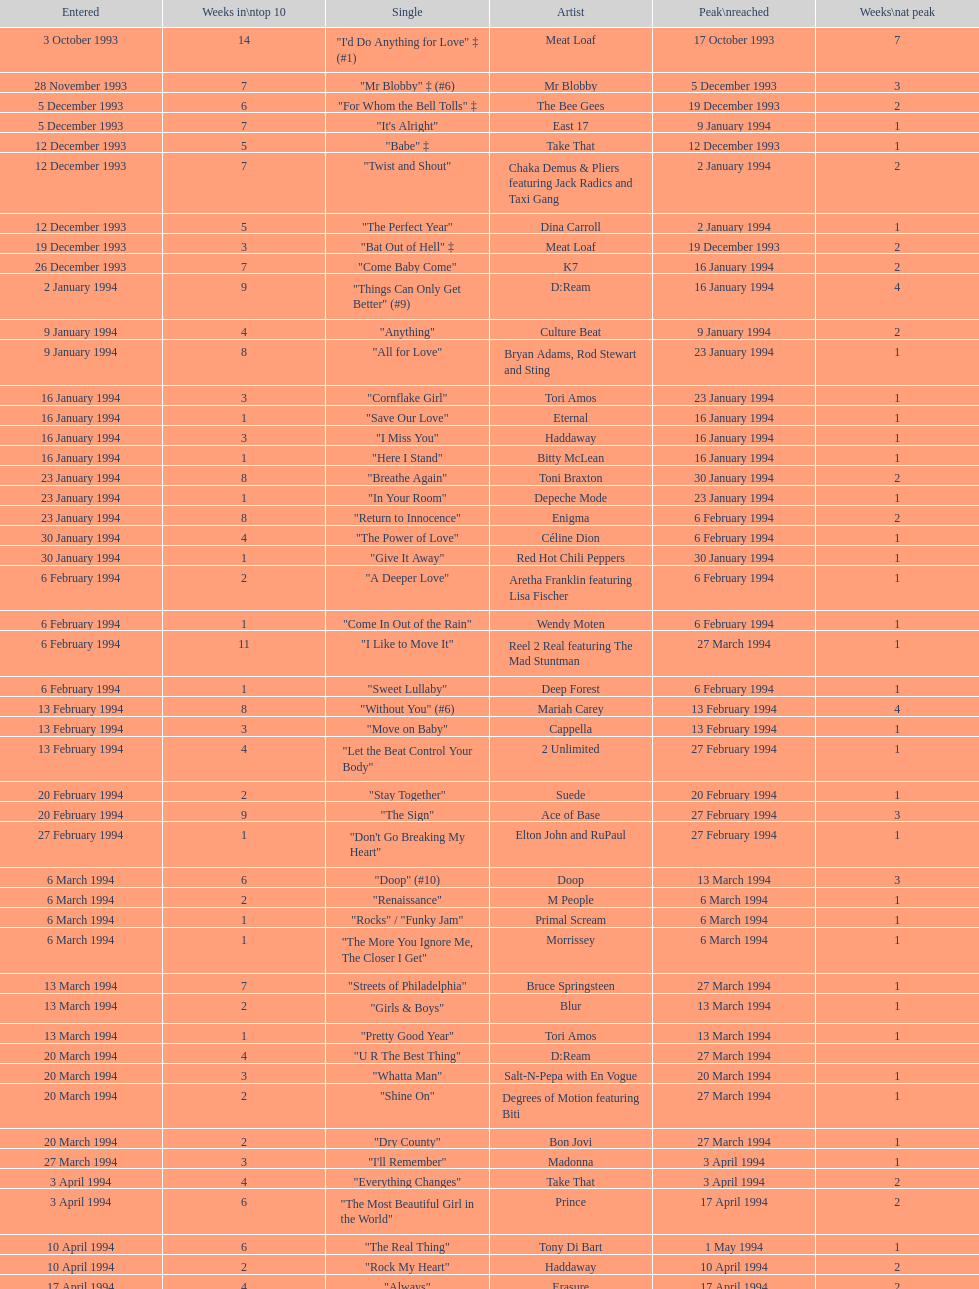Which single was the last one to be on the charts in 1993? "Come Baby Come". 